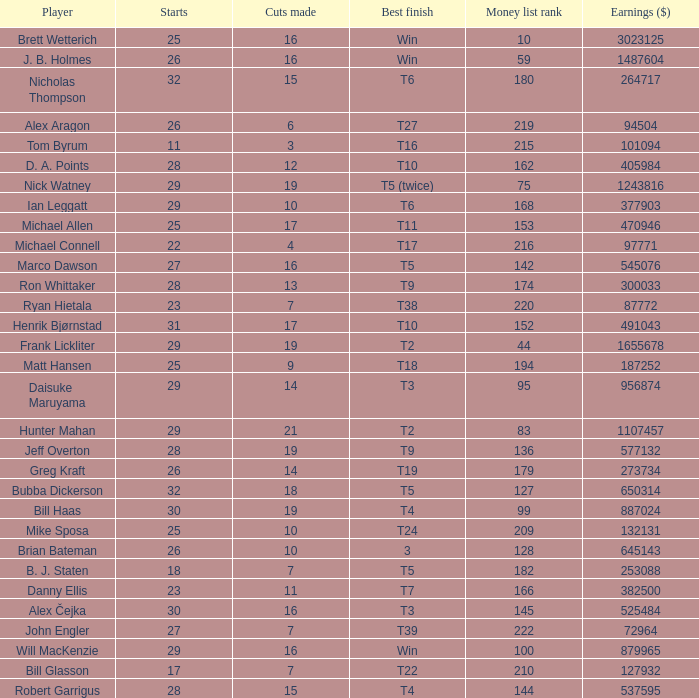What is the minimum money list rank for the players having a best finish of T9? 136.0. 